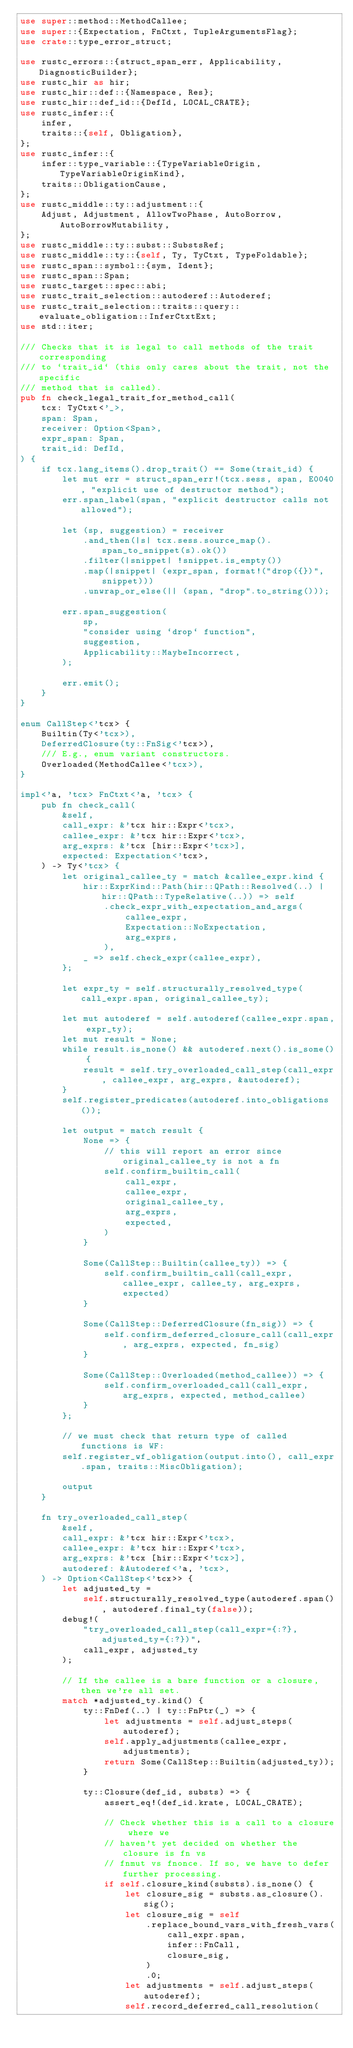Convert code to text. <code><loc_0><loc_0><loc_500><loc_500><_Rust_>use super::method::MethodCallee;
use super::{Expectation, FnCtxt, TupleArgumentsFlag};
use crate::type_error_struct;

use rustc_errors::{struct_span_err, Applicability, DiagnosticBuilder};
use rustc_hir as hir;
use rustc_hir::def::{Namespace, Res};
use rustc_hir::def_id::{DefId, LOCAL_CRATE};
use rustc_infer::{
    infer,
    traits::{self, Obligation},
};
use rustc_infer::{
    infer::type_variable::{TypeVariableOrigin, TypeVariableOriginKind},
    traits::ObligationCause,
};
use rustc_middle::ty::adjustment::{
    Adjust, Adjustment, AllowTwoPhase, AutoBorrow, AutoBorrowMutability,
};
use rustc_middle::ty::subst::SubstsRef;
use rustc_middle::ty::{self, Ty, TyCtxt, TypeFoldable};
use rustc_span::symbol::{sym, Ident};
use rustc_span::Span;
use rustc_target::spec::abi;
use rustc_trait_selection::autoderef::Autoderef;
use rustc_trait_selection::traits::query::evaluate_obligation::InferCtxtExt;
use std::iter;

/// Checks that it is legal to call methods of the trait corresponding
/// to `trait_id` (this only cares about the trait, not the specific
/// method that is called).
pub fn check_legal_trait_for_method_call(
    tcx: TyCtxt<'_>,
    span: Span,
    receiver: Option<Span>,
    expr_span: Span,
    trait_id: DefId,
) {
    if tcx.lang_items().drop_trait() == Some(trait_id) {
        let mut err = struct_span_err!(tcx.sess, span, E0040, "explicit use of destructor method");
        err.span_label(span, "explicit destructor calls not allowed");

        let (sp, suggestion) = receiver
            .and_then(|s| tcx.sess.source_map().span_to_snippet(s).ok())
            .filter(|snippet| !snippet.is_empty())
            .map(|snippet| (expr_span, format!("drop({})", snippet)))
            .unwrap_or_else(|| (span, "drop".to_string()));

        err.span_suggestion(
            sp,
            "consider using `drop` function",
            suggestion,
            Applicability::MaybeIncorrect,
        );

        err.emit();
    }
}

enum CallStep<'tcx> {
    Builtin(Ty<'tcx>),
    DeferredClosure(ty::FnSig<'tcx>),
    /// E.g., enum variant constructors.
    Overloaded(MethodCallee<'tcx>),
}

impl<'a, 'tcx> FnCtxt<'a, 'tcx> {
    pub fn check_call(
        &self,
        call_expr: &'tcx hir::Expr<'tcx>,
        callee_expr: &'tcx hir::Expr<'tcx>,
        arg_exprs: &'tcx [hir::Expr<'tcx>],
        expected: Expectation<'tcx>,
    ) -> Ty<'tcx> {
        let original_callee_ty = match &callee_expr.kind {
            hir::ExprKind::Path(hir::QPath::Resolved(..) | hir::QPath::TypeRelative(..)) => self
                .check_expr_with_expectation_and_args(
                    callee_expr,
                    Expectation::NoExpectation,
                    arg_exprs,
                ),
            _ => self.check_expr(callee_expr),
        };

        let expr_ty = self.structurally_resolved_type(call_expr.span, original_callee_ty);

        let mut autoderef = self.autoderef(callee_expr.span, expr_ty);
        let mut result = None;
        while result.is_none() && autoderef.next().is_some() {
            result = self.try_overloaded_call_step(call_expr, callee_expr, arg_exprs, &autoderef);
        }
        self.register_predicates(autoderef.into_obligations());

        let output = match result {
            None => {
                // this will report an error since original_callee_ty is not a fn
                self.confirm_builtin_call(
                    call_expr,
                    callee_expr,
                    original_callee_ty,
                    arg_exprs,
                    expected,
                )
            }

            Some(CallStep::Builtin(callee_ty)) => {
                self.confirm_builtin_call(call_expr, callee_expr, callee_ty, arg_exprs, expected)
            }

            Some(CallStep::DeferredClosure(fn_sig)) => {
                self.confirm_deferred_closure_call(call_expr, arg_exprs, expected, fn_sig)
            }

            Some(CallStep::Overloaded(method_callee)) => {
                self.confirm_overloaded_call(call_expr, arg_exprs, expected, method_callee)
            }
        };

        // we must check that return type of called functions is WF:
        self.register_wf_obligation(output.into(), call_expr.span, traits::MiscObligation);

        output
    }

    fn try_overloaded_call_step(
        &self,
        call_expr: &'tcx hir::Expr<'tcx>,
        callee_expr: &'tcx hir::Expr<'tcx>,
        arg_exprs: &'tcx [hir::Expr<'tcx>],
        autoderef: &Autoderef<'a, 'tcx>,
    ) -> Option<CallStep<'tcx>> {
        let adjusted_ty =
            self.structurally_resolved_type(autoderef.span(), autoderef.final_ty(false));
        debug!(
            "try_overloaded_call_step(call_expr={:?}, adjusted_ty={:?})",
            call_expr, adjusted_ty
        );

        // If the callee is a bare function or a closure, then we're all set.
        match *adjusted_ty.kind() {
            ty::FnDef(..) | ty::FnPtr(_) => {
                let adjustments = self.adjust_steps(autoderef);
                self.apply_adjustments(callee_expr, adjustments);
                return Some(CallStep::Builtin(adjusted_ty));
            }

            ty::Closure(def_id, substs) => {
                assert_eq!(def_id.krate, LOCAL_CRATE);

                // Check whether this is a call to a closure where we
                // haven't yet decided on whether the closure is fn vs
                // fnmut vs fnonce. If so, we have to defer further processing.
                if self.closure_kind(substs).is_none() {
                    let closure_sig = substs.as_closure().sig();
                    let closure_sig = self
                        .replace_bound_vars_with_fresh_vars(
                            call_expr.span,
                            infer::FnCall,
                            closure_sig,
                        )
                        .0;
                    let adjustments = self.adjust_steps(autoderef);
                    self.record_deferred_call_resolution(</code> 